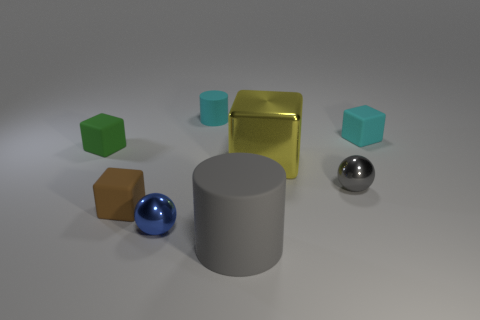Add 2 large yellow cubes. How many objects exist? 10 Subtract all spheres. How many objects are left? 6 Subtract all blue spheres. Subtract all large yellow things. How many objects are left? 6 Add 6 gray objects. How many gray objects are left? 8 Add 3 small purple rubber blocks. How many small purple rubber blocks exist? 3 Subtract 0 purple spheres. How many objects are left? 8 